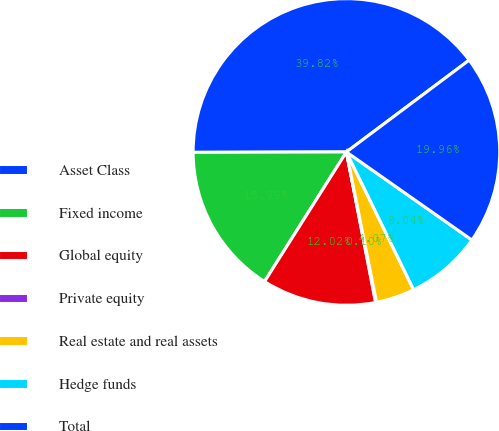Convert chart to OTSL. <chart><loc_0><loc_0><loc_500><loc_500><pie_chart><fcel>Asset Class<fcel>Fixed income<fcel>Global equity<fcel>Private equity<fcel>Real estate and real assets<fcel>Hedge funds<fcel>Total<nl><fcel>39.82%<fcel>15.99%<fcel>12.02%<fcel>0.1%<fcel>4.07%<fcel>8.04%<fcel>19.96%<nl></chart> 